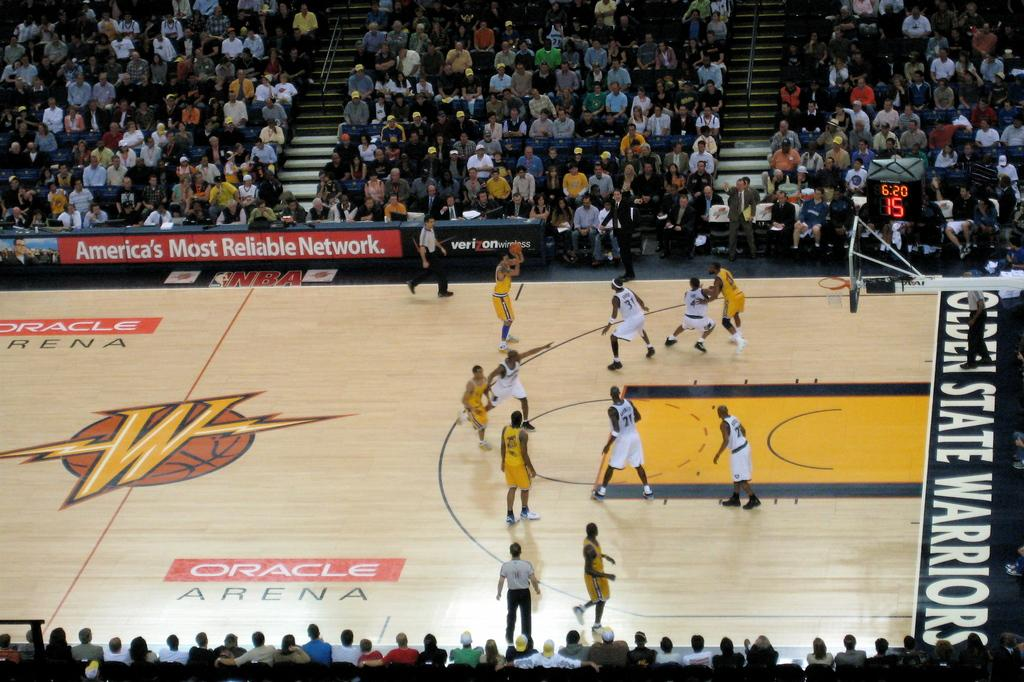<image>
Create a compact narrative representing the image presented. basketball players on a court reading Oracle Arena in the midst of a game 